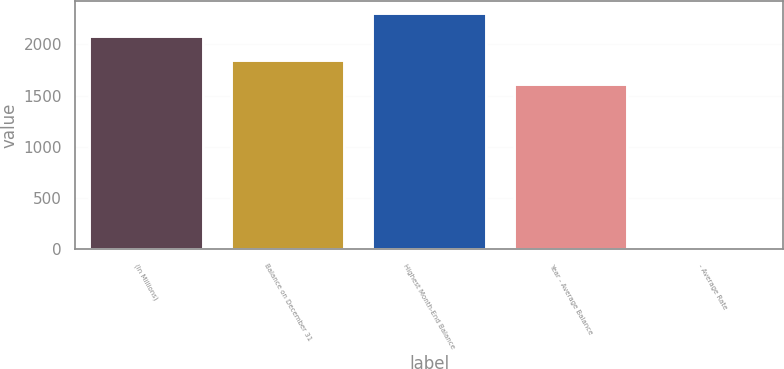Convert chart. <chart><loc_0><loc_0><loc_500><loc_500><bar_chart><fcel>(In Millions)<fcel>Balance on December 31<fcel>Highest Month-End Balance<fcel>Year - Average Balance<fcel>- Average Rate<nl><fcel>2078.82<fcel>1848.06<fcel>2309.58<fcel>1617.3<fcel>0.21<nl></chart> 